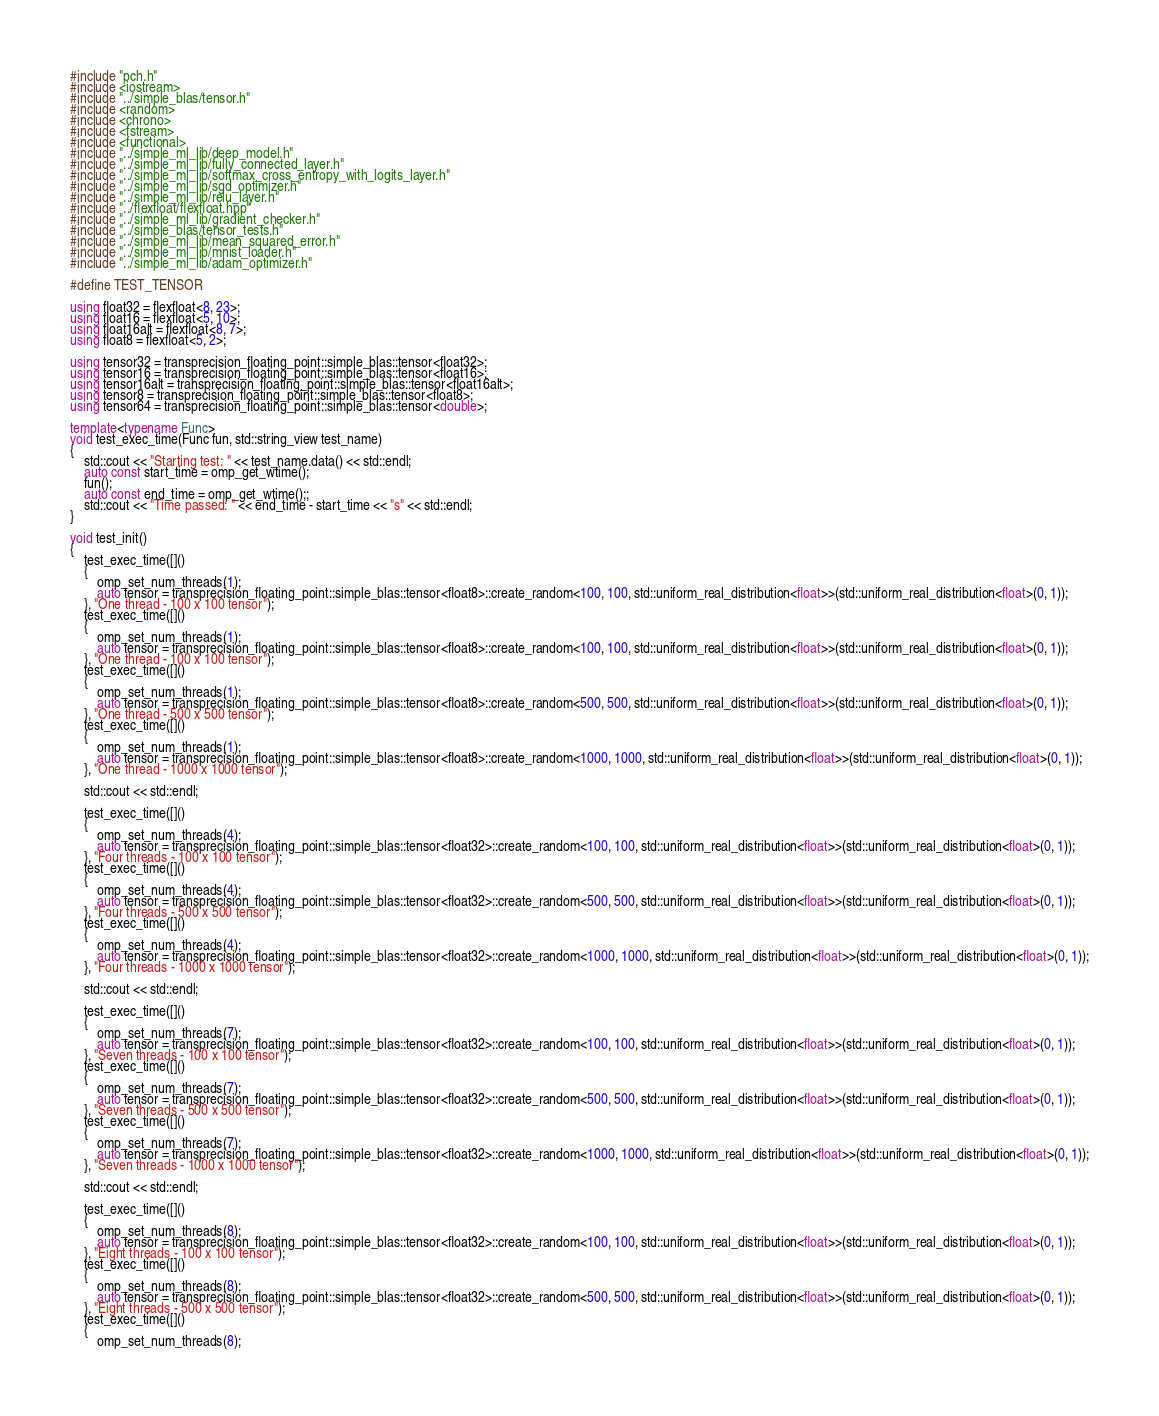Convert code to text. <code><loc_0><loc_0><loc_500><loc_500><_C++_>#include "pch.h"
#include <iostream>
#include "../simple_blas/tensor.h"
#include <random>
#include <chrono>
#include <fstream>
#include <functional>
#include "../simple_ml_lib/deep_model.h"
#include "../simple_ml_lib/fully_connected_layer.h"
#include "../simple_ml_lib/softmax_cross_entropy_with_logits_layer.h"
#include "../simple_ml_lib/sgd_optimizer.h"
#include "../simple_ml_lib/relu_layer.h"
#include "../flexfloat/flexfloat.hpp"
#include "../simple_ml_lib/gradient_checker.h"
#include "../simple_blas/tensor_tests.h"
#include "../simple_ml_lib/mean_squared_error.h"
#include "../simple_ml_lib/mnist_loader.h"
#include "../simple_ml_lib/adam_optimizer.h"

#define TEST_TENSOR

using float32 = flexfloat<8, 23>;
using float16 = flexfloat<5, 10>;
using float16alt = flexfloat<8, 7>;
using float8 = flexfloat<5, 2>;

using tensor32 = transprecision_floating_point::simple_blas::tensor<float32>;
using tensor16 = transprecision_floating_point::simple_blas::tensor<float16>;
using tensor16alt = transprecision_floating_point::simple_blas::tensor<float16alt>;
using tensor8 = transprecision_floating_point::simple_blas::tensor<float8>;
using tensor64 = transprecision_floating_point::simple_blas::tensor<double>;

template<typename Func>
void test_exec_time(Func fun, std::string_view test_name)
{
	std::cout << "Starting test: " << test_name.data() << std::endl;
	auto const start_time = omp_get_wtime();
	fun();
	auto const end_time = omp_get_wtime();;
	std::cout << "Time passed: " << end_time - start_time << "s" << std::endl;
}

void test_init()
{
	test_exec_time([]()
	{
		omp_set_num_threads(1);
		auto tensor = transprecision_floating_point::simple_blas::tensor<float8>::create_random<100, 100, std::uniform_real_distribution<float>>(std::uniform_real_distribution<float>(0, 1));
	}, "One thread - 100 x 100 tensor");
	test_exec_time([]()
	{
		omp_set_num_threads(1);
		auto tensor = transprecision_floating_point::simple_blas::tensor<float8>::create_random<100, 100, std::uniform_real_distribution<float>>(std::uniform_real_distribution<float>(0, 1));
	}, "One thread - 100 x 100 tensor");
	test_exec_time([]()
	{
		omp_set_num_threads(1);
		auto tensor = transprecision_floating_point::simple_blas::tensor<float8>::create_random<500, 500, std::uniform_real_distribution<float>>(std::uniform_real_distribution<float>(0, 1));
	}, "One thread - 500 x 500 tensor");
	test_exec_time([]()
	{
		omp_set_num_threads(1);
		auto tensor = transprecision_floating_point::simple_blas::tensor<float8>::create_random<1000, 1000, std::uniform_real_distribution<float>>(std::uniform_real_distribution<float>(0, 1));
	}, "One thread - 1000 x 1000 tensor");

	std::cout << std::endl;

	test_exec_time([]()
	{
		omp_set_num_threads(4);
		auto tensor = transprecision_floating_point::simple_blas::tensor<float32>::create_random<100, 100, std::uniform_real_distribution<float>>(std::uniform_real_distribution<float>(0, 1));
	}, "Four threads - 100 x 100 tensor");
	test_exec_time([]()
	{
		omp_set_num_threads(4);
		auto tensor = transprecision_floating_point::simple_blas::tensor<float32>::create_random<500, 500, std::uniform_real_distribution<float>>(std::uniform_real_distribution<float>(0, 1));
	}, "Four threads - 500 x 500 tensor");
	test_exec_time([]()
	{
		omp_set_num_threads(4);
		auto tensor = transprecision_floating_point::simple_blas::tensor<float32>::create_random<1000, 1000, std::uniform_real_distribution<float>>(std::uniform_real_distribution<float>(0, 1));
	}, "Four threads - 1000 x 1000 tensor");

	std::cout << std::endl;

	test_exec_time([]()
	{
		omp_set_num_threads(7);
		auto tensor = transprecision_floating_point::simple_blas::tensor<float32>::create_random<100, 100, std::uniform_real_distribution<float>>(std::uniform_real_distribution<float>(0, 1));
	}, "Seven threads - 100 x 100 tensor");
	test_exec_time([]()
	{
		omp_set_num_threads(7);
		auto tensor = transprecision_floating_point::simple_blas::tensor<float32>::create_random<500, 500, std::uniform_real_distribution<float>>(std::uniform_real_distribution<float>(0, 1));
	}, "Seven threads - 500 x 500 tensor");
	test_exec_time([]()
	{
		omp_set_num_threads(7);
		auto tensor = transprecision_floating_point::simple_blas::tensor<float32>::create_random<1000, 1000, std::uniform_real_distribution<float>>(std::uniform_real_distribution<float>(0, 1));
	}, "Seven threads - 1000 x 1000 tensor");

	std::cout << std::endl;

	test_exec_time([]()
	{
		omp_set_num_threads(8);
		auto tensor = transprecision_floating_point::simple_blas::tensor<float32>::create_random<100, 100, std::uniform_real_distribution<float>>(std::uniform_real_distribution<float>(0, 1));
	}, "Eight threads - 100 x 100 tensor");
	test_exec_time([]()
	{
		omp_set_num_threads(8);
		auto tensor = transprecision_floating_point::simple_blas::tensor<float32>::create_random<500, 500, std::uniform_real_distribution<float>>(std::uniform_real_distribution<float>(0, 1));
	}, "Eight threads - 500 x 500 tensor");
	test_exec_time([]()
	{
		omp_set_num_threads(8);</code> 